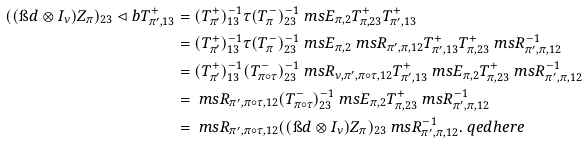Convert formula to latex. <formula><loc_0><loc_0><loc_500><loc_500>( ( \i d \otimes I _ { \nu } ) Z _ { \pi } ) _ { 2 3 } \lhd b T _ { \pi ^ { \prime } , 1 3 } ^ { + } & = ( T _ { \pi ^ { \prime } } ^ { + } ) ^ { - 1 } _ { 1 3 } \tau ( T _ { \pi } ^ { - } ) _ { 2 3 } ^ { - 1 } \ m s E _ { \pi , 2 } T ^ { + } _ { \pi , 2 3 } T _ { \pi ^ { \prime } , 1 3 } ^ { + } \\ & = ( T _ { \pi ^ { \prime } } ^ { + } ) ^ { - 1 } _ { 1 3 } \tau ( T _ { \pi } ^ { - } ) _ { 2 3 } ^ { - 1 } \ m s E _ { \pi , 2 } \ m s R _ { \pi ^ { \prime } , \pi , 1 2 } T ^ { + } _ { \pi ^ { \prime } , 1 3 } T _ { \pi , 2 3 } ^ { + } \ m s R _ { \pi ^ { \prime } , \pi , 1 2 } ^ { - 1 } \\ & = ( T _ { \pi ^ { \prime } } ^ { + } ) ^ { - 1 } _ { 1 3 } ( T _ { \pi \circ \tau } ^ { - } ) _ { 2 3 } ^ { - 1 } \ m s R _ { \nu , \pi ^ { \prime } , \pi \circ \tau , 1 2 } T ^ { + } _ { \pi ^ { \prime } , 1 3 } \ m s E _ { \pi , 2 } T _ { \pi , 2 3 } ^ { + } \ m s R _ { \pi ^ { \prime } , \pi , 1 2 } ^ { - 1 } \\ & = \ m s R _ { \pi ^ { \prime } , \pi \circ \tau , 1 2 } ( T _ { \pi \circ \tau } ^ { - } ) _ { 2 3 } ^ { - 1 } \ m s E _ { \pi , 2 } T _ { \pi , 2 3 } ^ { + } \ m s R _ { \pi ^ { \prime } , \pi , 1 2 } ^ { - 1 } \\ & = \ m s R _ { \pi ^ { \prime } , \pi \circ \tau , 1 2 } ( ( \i d \otimes I _ { \nu } ) Z _ { \pi } ) _ { 2 3 } \ m s R _ { \pi ^ { \prime } , \pi , 1 2 } ^ { - 1 } . \ q e d h e r e</formula> 